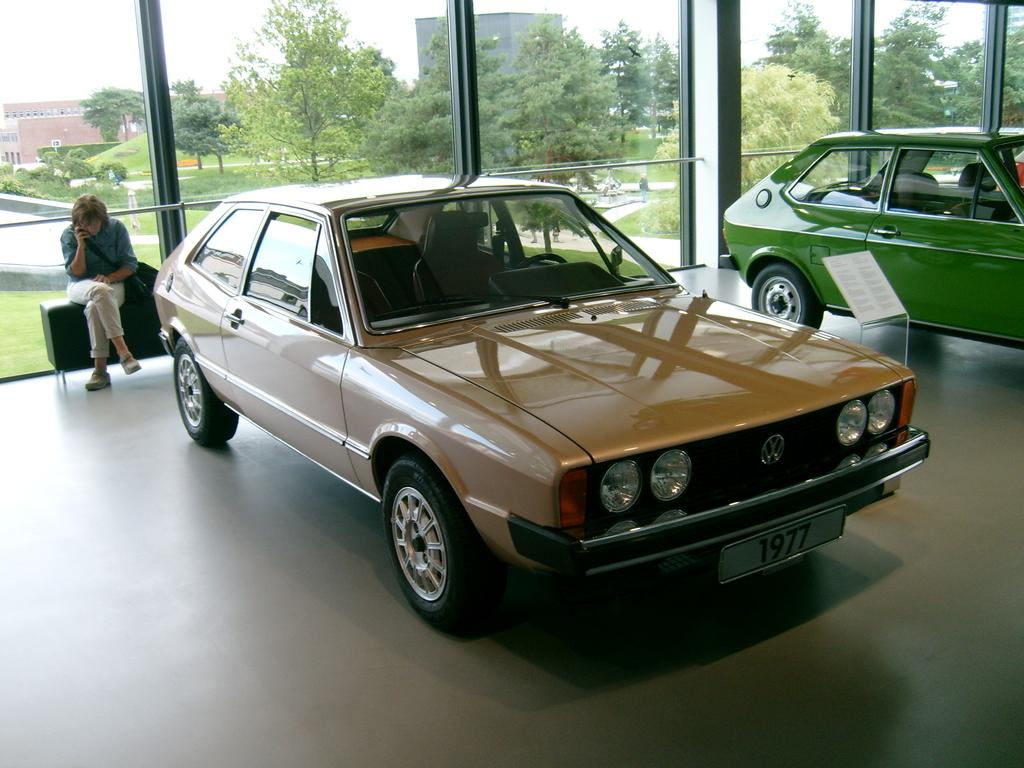What is the person in the image doing? The person is sitting on a chair. What is the person wearing that is visible in the image? The person is wearing a bag. What type of vehicles can be seen in the image? Cars are visible in the image. What is the board with a stand on the floor used for? The purpose of the board with a stand on the floor is not specified in the facts. What is inside the glass in the image? The contents of the glass are not specified in the facts. What can be seen through the glass in the image? Trees, grass, buildings, and the sky can be seen through the glass. What type of calendar is hanging on the wall in the image? There is no mention of a calendar in the image, so it cannot be determined if one is present. 